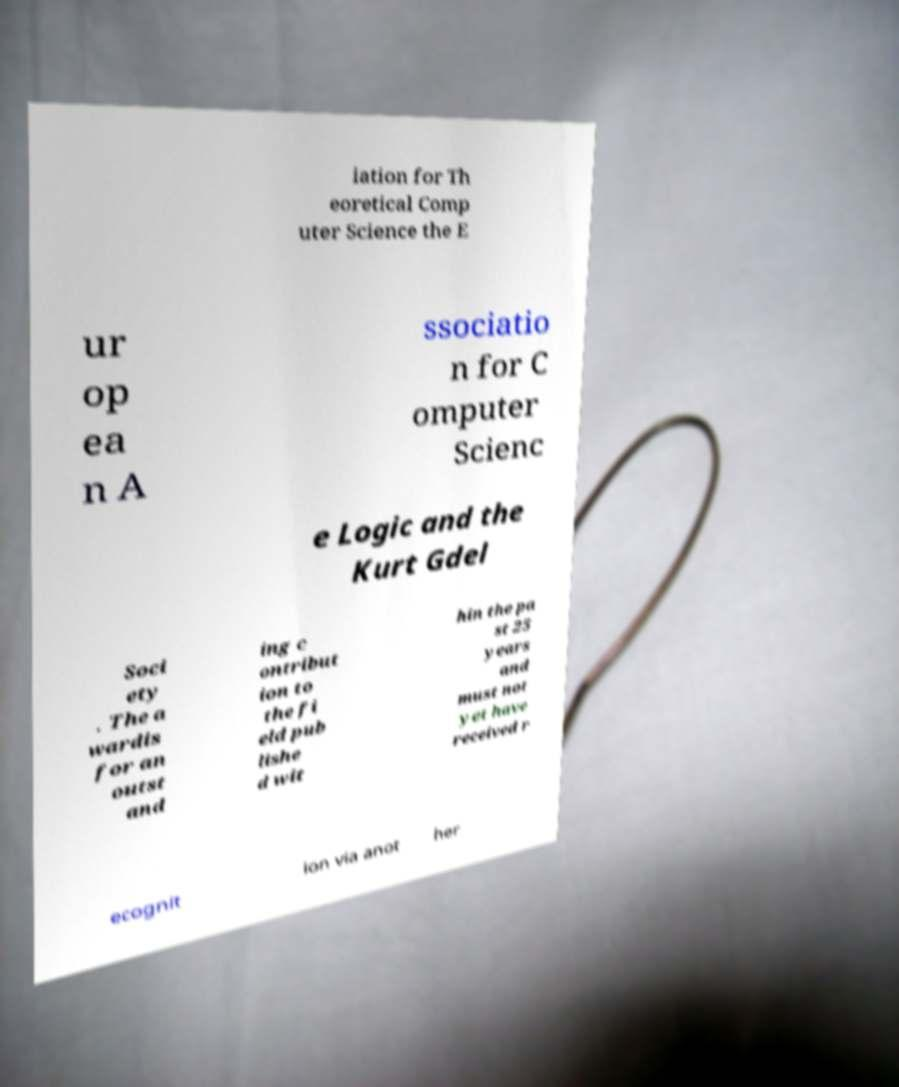What messages or text are displayed in this image? I need them in a readable, typed format. iation for Th eoretical Comp uter Science the E ur op ea n A ssociatio n for C omputer Scienc e Logic and the Kurt Gdel Soci ety . The a wardis for an outst and ing c ontribut ion to the fi eld pub lishe d wit hin the pa st 25 years and must not yet have received r ecognit ion via anot her 